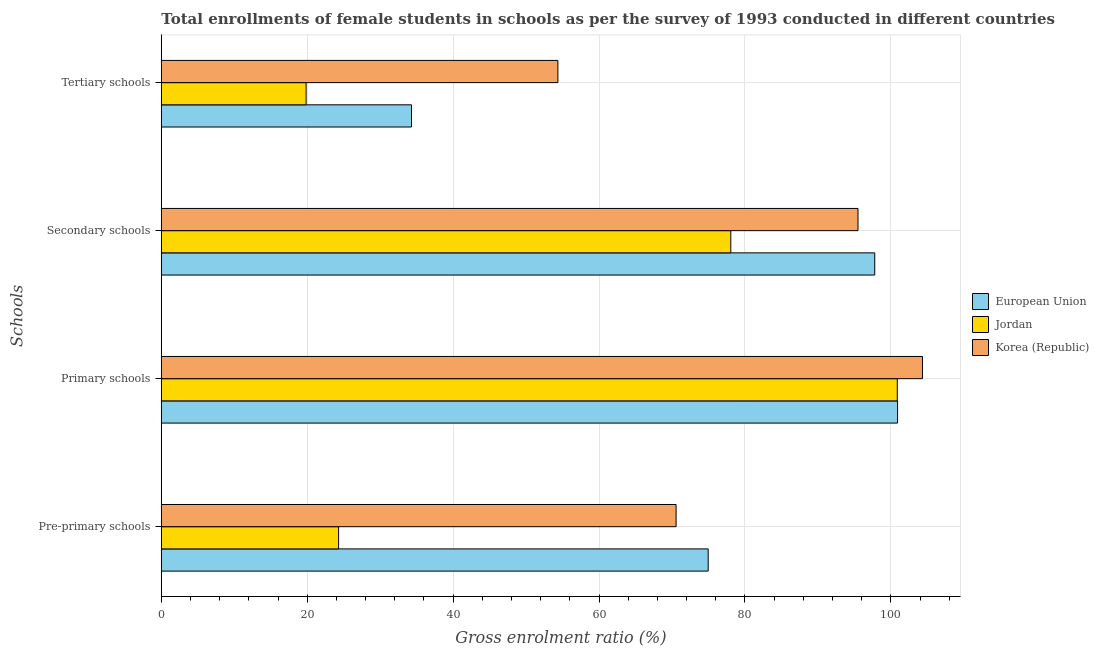How many different coloured bars are there?
Offer a very short reply. 3. Are the number of bars per tick equal to the number of legend labels?
Ensure brevity in your answer.  Yes. How many bars are there on the 3rd tick from the top?
Offer a terse response. 3. What is the label of the 3rd group of bars from the top?
Your answer should be very brief. Primary schools. What is the gross enrolment ratio(female) in secondary schools in Korea (Republic)?
Offer a terse response. 95.5. Across all countries, what is the maximum gross enrolment ratio(female) in pre-primary schools?
Your answer should be compact. 74.96. Across all countries, what is the minimum gross enrolment ratio(female) in secondary schools?
Provide a succinct answer. 78.06. In which country was the gross enrolment ratio(female) in primary schools minimum?
Give a very brief answer. Jordan. What is the total gross enrolment ratio(female) in pre-primary schools in the graph?
Your response must be concise. 169.83. What is the difference between the gross enrolment ratio(female) in secondary schools in Korea (Republic) and that in European Union?
Ensure brevity in your answer.  -2.3. What is the difference between the gross enrolment ratio(female) in tertiary schools in European Union and the gross enrolment ratio(female) in primary schools in Korea (Republic)?
Offer a very short reply. -70.04. What is the average gross enrolment ratio(female) in pre-primary schools per country?
Provide a short and direct response. 56.61. What is the difference between the gross enrolment ratio(female) in secondary schools and gross enrolment ratio(female) in primary schools in Korea (Republic)?
Give a very brief answer. -8.83. In how many countries, is the gross enrolment ratio(female) in pre-primary schools greater than 36 %?
Offer a very short reply. 2. What is the ratio of the gross enrolment ratio(female) in tertiary schools in European Union to that in Jordan?
Give a very brief answer. 1.73. Is the gross enrolment ratio(female) in secondary schools in Jordan less than that in Korea (Republic)?
Your answer should be very brief. Yes. What is the difference between the highest and the second highest gross enrolment ratio(female) in primary schools?
Provide a succinct answer. 3.41. What is the difference between the highest and the lowest gross enrolment ratio(female) in pre-primary schools?
Make the answer very short. 50.66. Is it the case that in every country, the sum of the gross enrolment ratio(female) in secondary schools and gross enrolment ratio(female) in pre-primary schools is greater than the sum of gross enrolment ratio(female) in tertiary schools and gross enrolment ratio(female) in primary schools?
Provide a succinct answer. No. What does the 1st bar from the top in Pre-primary schools represents?
Ensure brevity in your answer.  Korea (Republic). Are all the bars in the graph horizontal?
Your response must be concise. Yes. What is the difference between two consecutive major ticks on the X-axis?
Keep it short and to the point. 20. Does the graph contain any zero values?
Your answer should be compact. No. Does the graph contain grids?
Keep it short and to the point. Yes. What is the title of the graph?
Your answer should be compact. Total enrollments of female students in schools as per the survey of 1993 conducted in different countries. Does "Latin America(all income levels)" appear as one of the legend labels in the graph?
Your answer should be very brief. No. What is the label or title of the X-axis?
Offer a very short reply. Gross enrolment ratio (%). What is the label or title of the Y-axis?
Ensure brevity in your answer.  Schools. What is the Gross enrolment ratio (%) in European Union in Pre-primary schools?
Give a very brief answer. 74.96. What is the Gross enrolment ratio (%) of Jordan in Pre-primary schools?
Offer a terse response. 24.3. What is the Gross enrolment ratio (%) in Korea (Republic) in Pre-primary schools?
Make the answer very short. 70.57. What is the Gross enrolment ratio (%) of European Union in Primary schools?
Provide a succinct answer. 100.92. What is the Gross enrolment ratio (%) in Jordan in Primary schools?
Your answer should be compact. 100.89. What is the Gross enrolment ratio (%) of Korea (Republic) in Primary schools?
Your response must be concise. 104.34. What is the Gross enrolment ratio (%) in European Union in Secondary schools?
Provide a short and direct response. 97.8. What is the Gross enrolment ratio (%) of Jordan in Secondary schools?
Your response must be concise. 78.06. What is the Gross enrolment ratio (%) of Korea (Republic) in Secondary schools?
Your answer should be compact. 95.5. What is the Gross enrolment ratio (%) of European Union in Tertiary schools?
Your response must be concise. 34.29. What is the Gross enrolment ratio (%) of Jordan in Tertiary schools?
Make the answer very short. 19.85. What is the Gross enrolment ratio (%) of Korea (Republic) in Tertiary schools?
Offer a terse response. 54.36. Across all Schools, what is the maximum Gross enrolment ratio (%) in European Union?
Provide a succinct answer. 100.92. Across all Schools, what is the maximum Gross enrolment ratio (%) in Jordan?
Offer a terse response. 100.89. Across all Schools, what is the maximum Gross enrolment ratio (%) in Korea (Republic)?
Keep it short and to the point. 104.34. Across all Schools, what is the minimum Gross enrolment ratio (%) in European Union?
Offer a very short reply. 34.29. Across all Schools, what is the minimum Gross enrolment ratio (%) in Jordan?
Your answer should be very brief. 19.85. Across all Schools, what is the minimum Gross enrolment ratio (%) of Korea (Republic)?
Provide a succinct answer. 54.36. What is the total Gross enrolment ratio (%) of European Union in the graph?
Offer a very short reply. 307.98. What is the total Gross enrolment ratio (%) in Jordan in the graph?
Offer a very short reply. 223.1. What is the total Gross enrolment ratio (%) of Korea (Republic) in the graph?
Make the answer very short. 324.77. What is the difference between the Gross enrolment ratio (%) in European Union in Pre-primary schools and that in Primary schools?
Your answer should be compact. -25.96. What is the difference between the Gross enrolment ratio (%) of Jordan in Pre-primary schools and that in Primary schools?
Keep it short and to the point. -76.58. What is the difference between the Gross enrolment ratio (%) in Korea (Republic) in Pre-primary schools and that in Primary schools?
Your answer should be compact. -33.77. What is the difference between the Gross enrolment ratio (%) of European Union in Pre-primary schools and that in Secondary schools?
Provide a short and direct response. -22.83. What is the difference between the Gross enrolment ratio (%) of Jordan in Pre-primary schools and that in Secondary schools?
Your answer should be compact. -53.76. What is the difference between the Gross enrolment ratio (%) in Korea (Republic) in Pre-primary schools and that in Secondary schools?
Keep it short and to the point. -24.94. What is the difference between the Gross enrolment ratio (%) in European Union in Pre-primary schools and that in Tertiary schools?
Provide a succinct answer. 40.67. What is the difference between the Gross enrolment ratio (%) of Jordan in Pre-primary schools and that in Tertiary schools?
Keep it short and to the point. 4.46. What is the difference between the Gross enrolment ratio (%) in Korea (Republic) in Pre-primary schools and that in Tertiary schools?
Your answer should be compact. 16.2. What is the difference between the Gross enrolment ratio (%) of European Union in Primary schools and that in Secondary schools?
Provide a succinct answer. 3.13. What is the difference between the Gross enrolment ratio (%) in Jordan in Primary schools and that in Secondary schools?
Give a very brief answer. 22.82. What is the difference between the Gross enrolment ratio (%) of Korea (Republic) in Primary schools and that in Secondary schools?
Your response must be concise. 8.83. What is the difference between the Gross enrolment ratio (%) of European Union in Primary schools and that in Tertiary schools?
Give a very brief answer. 66.63. What is the difference between the Gross enrolment ratio (%) of Jordan in Primary schools and that in Tertiary schools?
Offer a very short reply. 81.04. What is the difference between the Gross enrolment ratio (%) in Korea (Republic) in Primary schools and that in Tertiary schools?
Offer a terse response. 49.97. What is the difference between the Gross enrolment ratio (%) of European Union in Secondary schools and that in Tertiary schools?
Provide a short and direct response. 63.5. What is the difference between the Gross enrolment ratio (%) of Jordan in Secondary schools and that in Tertiary schools?
Your response must be concise. 58.22. What is the difference between the Gross enrolment ratio (%) in Korea (Republic) in Secondary schools and that in Tertiary schools?
Your response must be concise. 41.14. What is the difference between the Gross enrolment ratio (%) in European Union in Pre-primary schools and the Gross enrolment ratio (%) in Jordan in Primary schools?
Offer a terse response. -25.92. What is the difference between the Gross enrolment ratio (%) of European Union in Pre-primary schools and the Gross enrolment ratio (%) of Korea (Republic) in Primary schools?
Your response must be concise. -29.37. What is the difference between the Gross enrolment ratio (%) in Jordan in Pre-primary schools and the Gross enrolment ratio (%) in Korea (Republic) in Primary schools?
Give a very brief answer. -80.03. What is the difference between the Gross enrolment ratio (%) in European Union in Pre-primary schools and the Gross enrolment ratio (%) in Jordan in Secondary schools?
Your answer should be compact. -3.1. What is the difference between the Gross enrolment ratio (%) in European Union in Pre-primary schools and the Gross enrolment ratio (%) in Korea (Republic) in Secondary schools?
Your answer should be compact. -20.54. What is the difference between the Gross enrolment ratio (%) in Jordan in Pre-primary schools and the Gross enrolment ratio (%) in Korea (Republic) in Secondary schools?
Ensure brevity in your answer.  -71.2. What is the difference between the Gross enrolment ratio (%) in European Union in Pre-primary schools and the Gross enrolment ratio (%) in Jordan in Tertiary schools?
Your response must be concise. 55.12. What is the difference between the Gross enrolment ratio (%) in European Union in Pre-primary schools and the Gross enrolment ratio (%) in Korea (Republic) in Tertiary schools?
Provide a succinct answer. 20.6. What is the difference between the Gross enrolment ratio (%) in Jordan in Pre-primary schools and the Gross enrolment ratio (%) in Korea (Republic) in Tertiary schools?
Provide a succinct answer. -30.06. What is the difference between the Gross enrolment ratio (%) of European Union in Primary schools and the Gross enrolment ratio (%) of Jordan in Secondary schools?
Offer a terse response. 22.86. What is the difference between the Gross enrolment ratio (%) in European Union in Primary schools and the Gross enrolment ratio (%) in Korea (Republic) in Secondary schools?
Make the answer very short. 5.42. What is the difference between the Gross enrolment ratio (%) of Jordan in Primary schools and the Gross enrolment ratio (%) of Korea (Republic) in Secondary schools?
Provide a succinct answer. 5.38. What is the difference between the Gross enrolment ratio (%) of European Union in Primary schools and the Gross enrolment ratio (%) of Jordan in Tertiary schools?
Your answer should be compact. 81.08. What is the difference between the Gross enrolment ratio (%) of European Union in Primary schools and the Gross enrolment ratio (%) of Korea (Republic) in Tertiary schools?
Your response must be concise. 46.56. What is the difference between the Gross enrolment ratio (%) of Jordan in Primary schools and the Gross enrolment ratio (%) of Korea (Republic) in Tertiary schools?
Your answer should be compact. 46.52. What is the difference between the Gross enrolment ratio (%) of European Union in Secondary schools and the Gross enrolment ratio (%) of Jordan in Tertiary schools?
Ensure brevity in your answer.  77.95. What is the difference between the Gross enrolment ratio (%) in European Union in Secondary schools and the Gross enrolment ratio (%) in Korea (Republic) in Tertiary schools?
Provide a short and direct response. 43.43. What is the difference between the Gross enrolment ratio (%) of Jordan in Secondary schools and the Gross enrolment ratio (%) of Korea (Republic) in Tertiary schools?
Your response must be concise. 23.7. What is the average Gross enrolment ratio (%) of European Union per Schools?
Offer a very short reply. 76.99. What is the average Gross enrolment ratio (%) in Jordan per Schools?
Make the answer very short. 55.77. What is the average Gross enrolment ratio (%) of Korea (Republic) per Schools?
Your response must be concise. 81.19. What is the difference between the Gross enrolment ratio (%) of European Union and Gross enrolment ratio (%) of Jordan in Pre-primary schools?
Offer a terse response. 50.66. What is the difference between the Gross enrolment ratio (%) of European Union and Gross enrolment ratio (%) of Korea (Republic) in Pre-primary schools?
Make the answer very short. 4.4. What is the difference between the Gross enrolment ratio (%) in Jordan and Gross enrolment ratio (%) in Korea (Republic) in Pre-primary schools?
Offer a very short reply. -46.26. What is the difference between the Gross enrolment ratio (%) in European Union and Gross enrolment ratio (%) in Jordan in Primary schools?
Provide a succinct answer. 0.04. What is the difference between the Gross enrolment ratio (%) of European Union and Gross enrolment ratio (%) of Korea (Republic) in Primary schools?
Offer a terse response. -3.41. What is the difference between the Gross enrolment ratio (%) of Jordan and Gross enrolment ratio (%) of Korea (Republic) in Primary schools?
Offer a very short reply. -3.45. What is the difference between the Gross enrolment ratio (%) in European Union and Gross enrolment ratio (%) in Jordan in Secondary schools?
Keep it short and to the point. 19.73. What is the difference between the Gross enrolment ratio (%) in European Union and Gross enrolment ratio (%) in Korea (Republic) in Secondary schools?
Ensure brevity in your answer.  2.3. What is the difference between the Gross enrolment ratio (%) of Jordan and Gross enrolment ratio (%) of Korea (Republic) in Secondary schools?
Provide a succinct answer. -17.44. What is the difference between the Gross enrolment ratio (%) of European Union and Gross enrolment ratio (%) of Jordan in Tertiary schools?
Your answer should be very brief. 14.45. What is the difference between the Gross enrolment ratio (%) in European Union and Gross enrolment ratio (%) in Korea (Republic) in Tertiary schools?
Your response must be concise. -20.07. What is the difference between the Gross enrolment ratio (%) in Jordan and Gross enrolment ratio (%) in Korea (Republic) in Tertiary schools?
Provide a succinct answer. -34.52. What is the ratio of the Gross enrolment ratio (%) in European Union in Pre-primary schools to that in Primary schools?
Offer a terse response. 0.74. What is the ratio of the Gross enrolment ratio (%) of Jordan in Pre-primary schools to that in Primary schools?
Make the answer very short. 0.24. What is the ratio of the Gross enrolment ratio (%) in Korea (Republic) in Pre-primary schools to that in Primary schools?
Ensure brevity in your answer.  0.68. What is the ratio of the Gross enrolment ratio (%) in European Union in Pre-primary schools to that in Secondary schools?
Ensure brevity in your answer.  0.77. What is the ratio of the Gross enrolment ratio (%) of Jordan in Pre-primary schools to that in Secondary schools?
Offer a terse response. 0.31. What is the ratio of the Gross enrolment ratio (%) of Korea (Republic) in Pre-primary schools to that in Secondary schools?
Ensure brevity in your answer.  0.74. What is the ratio of the Gross enrolment ratio (%) in European Union in Pre-primary schools to that in Tertiary schools?
Offer a very short reply. 2.19. What is the ratio of the Gross enrolment ratio (%) of Jordan in Pre-primary schools to that in Tertiary schools?
Provide a short and direct response. 1.22. What is the ratio of the Gross enrolment ratio (%) of Korea (Republic) in Pre-primary schools to that in Tertiary schools?
Provide a short and direct response. 1.3. What is the ratio of the Gross enrolment ratio (%) in European Union in Primary schools to that in Secondary schools?
Your answer should be compact. 1.03. What is the ratio of the Gross enrolment ratio (%) of Jordan in Primary schools to that in Secondary schools?
Provide a short and direct response. 1.29. What is the ratio of the Gross enrolment ratio (%) in Korea (Republic) in Primary schools to that in Secondary schools?
Keep it short and to the point. 1.09. What is the ratio of the Gross enrolment ratio (%) in European Union in Primary schools to that in Tertiary schools?
Provide a succinct answer. 2.94. What is the ratio of the Gross enrolment ratio (%) in Jordan in Primary schools to that in Tertiary schools?
Your answer should be compact. 5.08. What is the ratio of the Gross enrolment ratio (%) in Korea (Republic) in Primary schools to that in Tertiary schools?
Provide a succinct answer. 1.92. What is the ratio of the Gross enrolment ratio (%) in European Union in Secondary schools to that in Tertiary schools?
Ensure brevity in your answer.  2.85. What is the ratio of the Gross enrolment ratio (%) of Jordan in Secondary schools to that in Tertiary schools?
Offer a terse response. 3.93. What is the ratio of the Gross enrolment ratio (%) in Korea (Republic) in Secondary schools to that in Tertiary schools?
Ensure brevity in your answer.  1.76. What is the difference between the highest and the second highest Gross enrolment ratio (%) in European Union?
Ensure brevity in your answer.  3.13. What is the difference between the highest and the second highest Gross enrolment ratio (%) in Jordan?
Keep it short and to the point. 22.82. What is the difference between the highest and the second highest Gross enrolment ratio (%) in Korea (Republic)?
Provide a succinct answer. 8.83. What is the difference between the highest and the lowest Gross enrolment ratio (%) in European Union?
Keep it short and to the point. 66.63. What is the difference between the highest and the lowest Gross enrolment ratio (%) of Jordan?
Give a very brief answer. 81.04. What is the difference between the highest and the lowest Gross enrolment ratio (%) in Korea (Republic)?
Your answer should be very brief. 49.97. 